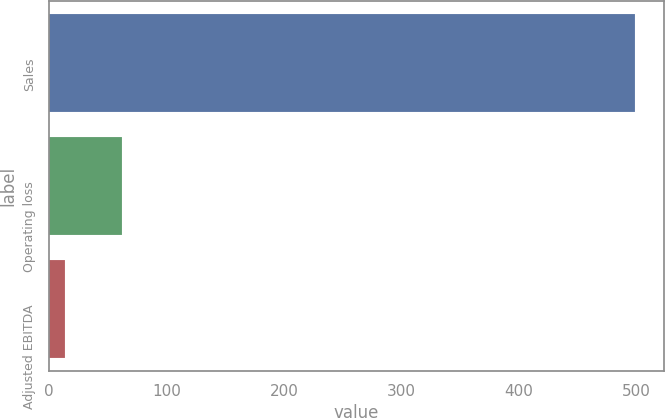<chart> <loc_0><loc_0><loc_500><loc_500><bar_chart><fcel>Sales<fcel>Operating loss<fcel>Adjusted EBITDA<nl><fcel>498.8<fcel>62.03<fcel>13.5<nl></chart> 